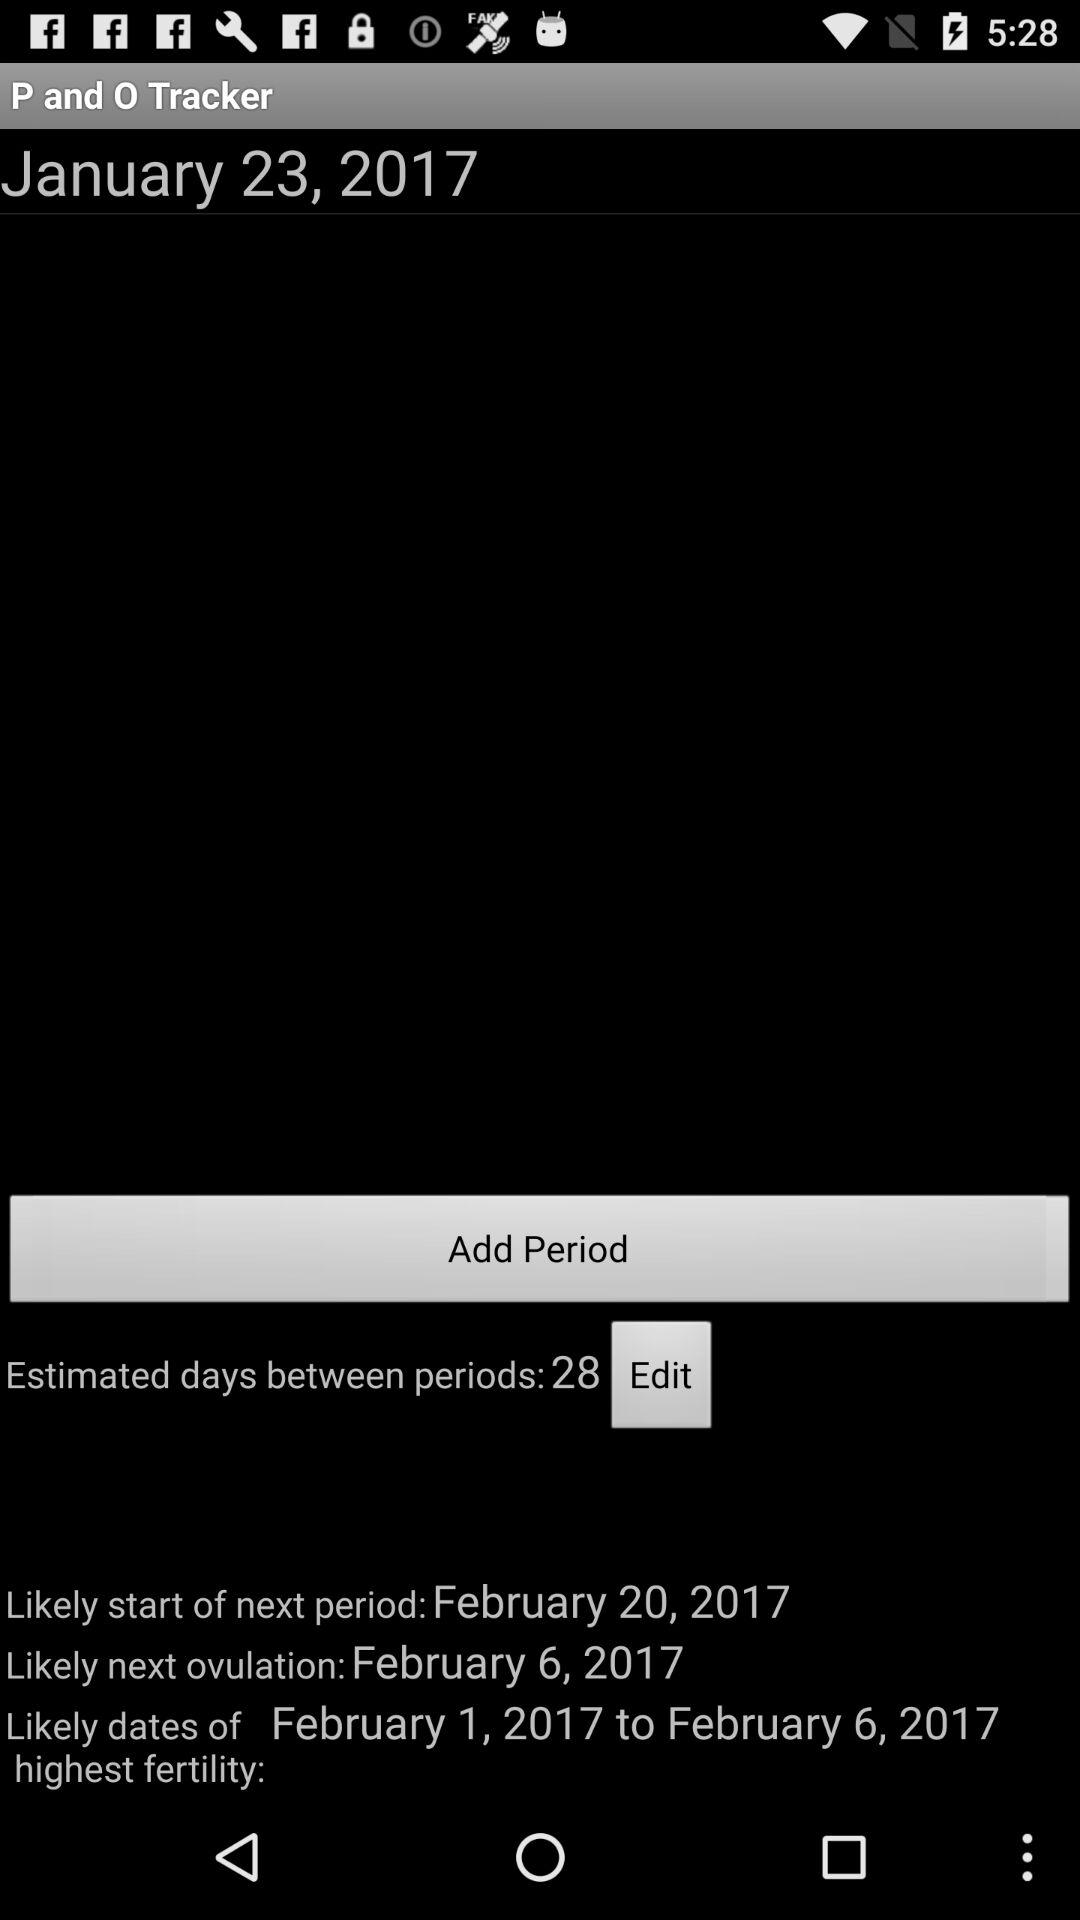What are the estimated days between periods? The estimated days between periods are 28. 